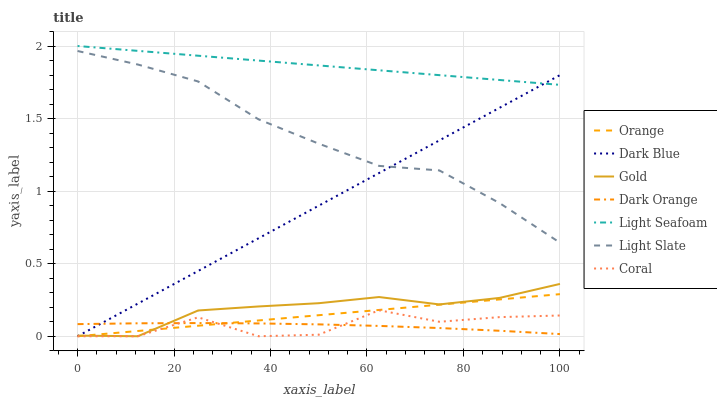Does Dark Orange have the minimum area under the curve?
Answer yes or no. Yes. Does Light Seafoam have the maximum area under the curve?
Answer yes or no. Yes. Does Gold have the minimum area under the curve?
Answer yes or no. No. Does Gold have the maximum area under the curve?
Answer yes or no. No. Is Orange the smoothest?
Answer yes or no. Yes. Is Coral the roughest?
Answer yes or no. Yes. Is Gold the smoothest?
Answer yes or no. No. Is Gold the roughest?
Answer yes or no. No. Does Gold have the lowest value?
Answer yes or no. Yes. Does Light Slate have the lowest value?
Answer yes or no. No. Does Light Seafoam have the highest value?
Answer yes or no. Yes. Does Gold have the highest value?
Answer yes or no. No. Is Orange less than Light Seafoam?
Answer yes or no. Yes. Is Light Seafoam greater than Orange?
Answer yes or no. Yes. Does Dark Blue intersect Light Slate?
Answer yes or no. Yes. Is Dark Blue less than Light Slate?
Answer yes or no. No. Is Dark Blue greater than Light Slate?
Answer yes or no. No. Does Orange intersect Light Seafoam?
Answer yes or no. No. 